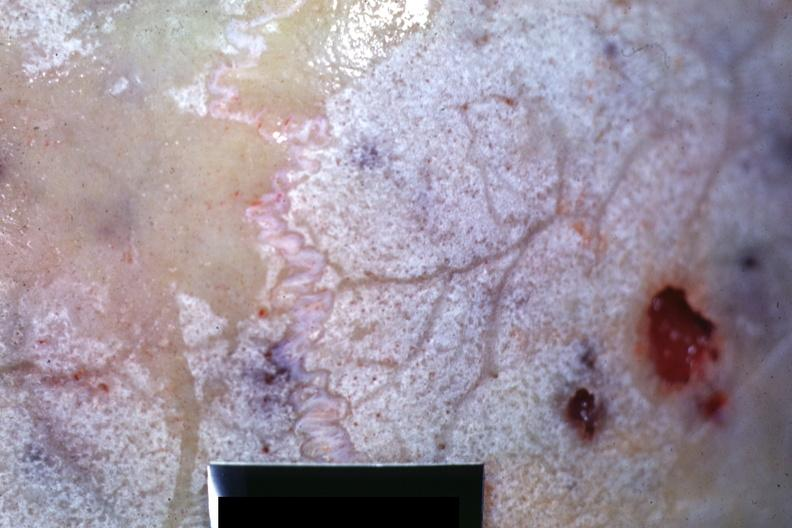does this image show close-up view of bone with hemorrhagic excavations?
Answer the question using a single word or phrase. Yes 